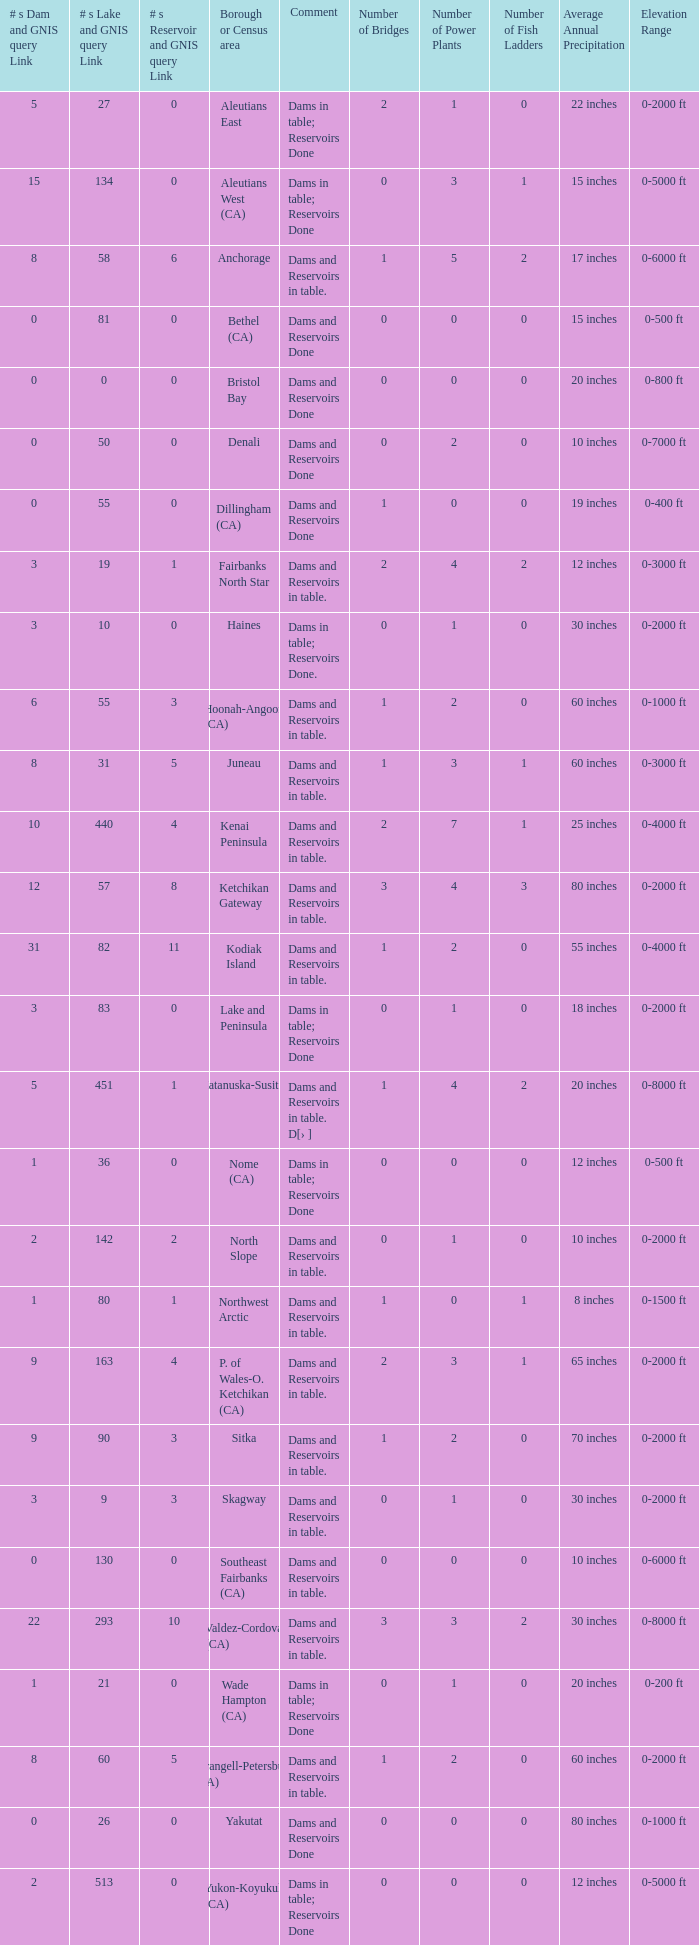Parse the full table. {'header': ['# s Dam and GNIS query Link', '# s Lake and GNIS query Link', '# s Reservoir and GNIS query Link', 'Borough or Census area', 'Comment', 'Number of Bridges', 'Number of Power Plants', 'Number of Fish Ladders', 'Average Annual Precipitation', 'Elevation Range'], 'rows': [['5', '27', '0', 'Aleutians East', 'Dams in table; Reservoirs Done', '2', '1', '0', '22 inches', '0-2000 ft'], ['15', '134', '0', 'Aleutians West (CA)', 'Dams in table; Reservoirs Done', '0', '3', '1', '15 inches', '0-5000 ft'], ['8', '58', '6', 'Anchorage', 'Dams and Reservoirs in table.', '1', '5', '2', '17 inches', '0-6000 ft'], ['0', '81', '0', 'Bethel (CA)', 'Dams and Reservoirs Done', '0', '0', '0', '15 inches', '0-500 ft'], ['0', '0', '0', 'Bristol Bay', 'Dams and Reservoirs Done', '0', '0', '0', '20 inches', '0-800 ft'], ['0', '50', '0', 'Denali', 'Dams and Reservoirs Done', '0', '2', '0', '10 inches', '0-7000 ft'], ['0', '55', '0', 'Dillingham (CA)', 'Dams and Reservoirs Done', '1', '0', '0', '19 inches', '0-400 ft'], ['3', '19', '1', 'Fairbanks North Star', 'Dams and Reservoirs in table.', '2', '4', '2', '12 inches', '0-3000 ft'], ['3', '10', '0', 'Haines', 'Dams in table; Reservoirs Done.', '0', '1', '0', '30 inches', '0-2000 ft'], ['6', '55', '3', 'Hoonah-Angoon (CA)', 'Dams and Reservoirs in table.', '1', '2', '0', '60 inches', '0-1000 ft'], ['8', '31', '5', 'Juneau', 'Dams and Reservoirs in table.', '1', '3', '1', '60 inches', '0-3000 ft'], ['10', '440', '4', 'Kenai Peninsula', 'Dams and Reservoirs in table.', '2', '7', '1', '25 inches', '0-4000 ft'], ['12', '57', '8', 'Ketchikan Gateway', 'Dams and Reservoirs in table.', '3', '4', '3', '80 inches', '0-2000 ft'], ['31', '82', '11', 'Kodiak Island', 'Dams and Reservoirs in table.', '1', '2', '0', '55 inches', '0-4000 ft'], ['3', '83', '0', 'Lake and Peninsula', 'Dams in table; Reservoirs Done', '0', '1', '0', '18 inches', '0-2000 ft'], ['5', '451', '1', 'Matanuska-Susitna', 'Dams and Reservoirs in table. D[› ]', '1', '4', '2', '20 inches', '0-8000 ft'], ['1', '36', '0', 'Nome (CA)', 'Dams in table; Reservoirs Done', '0', '0', '0', '12 inches', '0-500 ft'], ['2', '142', '2', 'North Slope', 'Dams and Reservoirs in table.', '0', '1', '0', '10 inches', '0-2000 ft'], ['1', '80', '1', 'Northwest Arctic', 'Dams and Reservoirs in table.', '1', '0', '1', '8 inches', '0-1500 ft'], ['9', '163', '4', 'P. of Wales-O. Ketchikan (CA)', 'Dams and Reservoirs in table.', '2', '3', '1', '65 inches', '0-2000 ft'], ['9', '90', '3', 'Sitka', 'Dams and Reservoirs in table.', '1', '2', '0', '70 inches', '0-2000 ft'], ['3', '9', '3', 'Skagway', 'Dams and Reservoirs in table.', '0', '1', '0', '30 inches', '0-2000 ft'], ['0', '130', '0', 'Southeast Fairbanks (CA)', 'Dams and Reservoirs in table.', '0', '0', '0', '10 inches', '0-6000 ft'], ['22', '293', '10', 'Valdez-Cordova (CA)', 'Dams and Reservoirs in table.', '3', '3', '2', '30 inches', '0-8000 ft'], ['1', '21', '0', 'Wade Hampton (CA)', 'Dams in table; Reservoirs Done', '0', '1', '0', '20 inches', '0-200 ft'], ['8', '60', '5', 'Wrangell-Petersburg (CA)', 'Dams and Reservoirs in table.', '1', '2', '0', '60 inches', '0-2000 ft'], ['0', '26', '0', 'Yakutat', 'Dams and Reservoirs Done', '0', '0', '0', '80 inches', '0-1000 ft'], ['2', '513', '0', 'Yukon-Koyukuk (CA)', 'Dams in table; Reservoirs Done', '0', '0', '0', '12 inches', '0-5000 ft']]} Name the most numbers dam and gnis query link for borough or census area for fairbanks north star 3.0. 